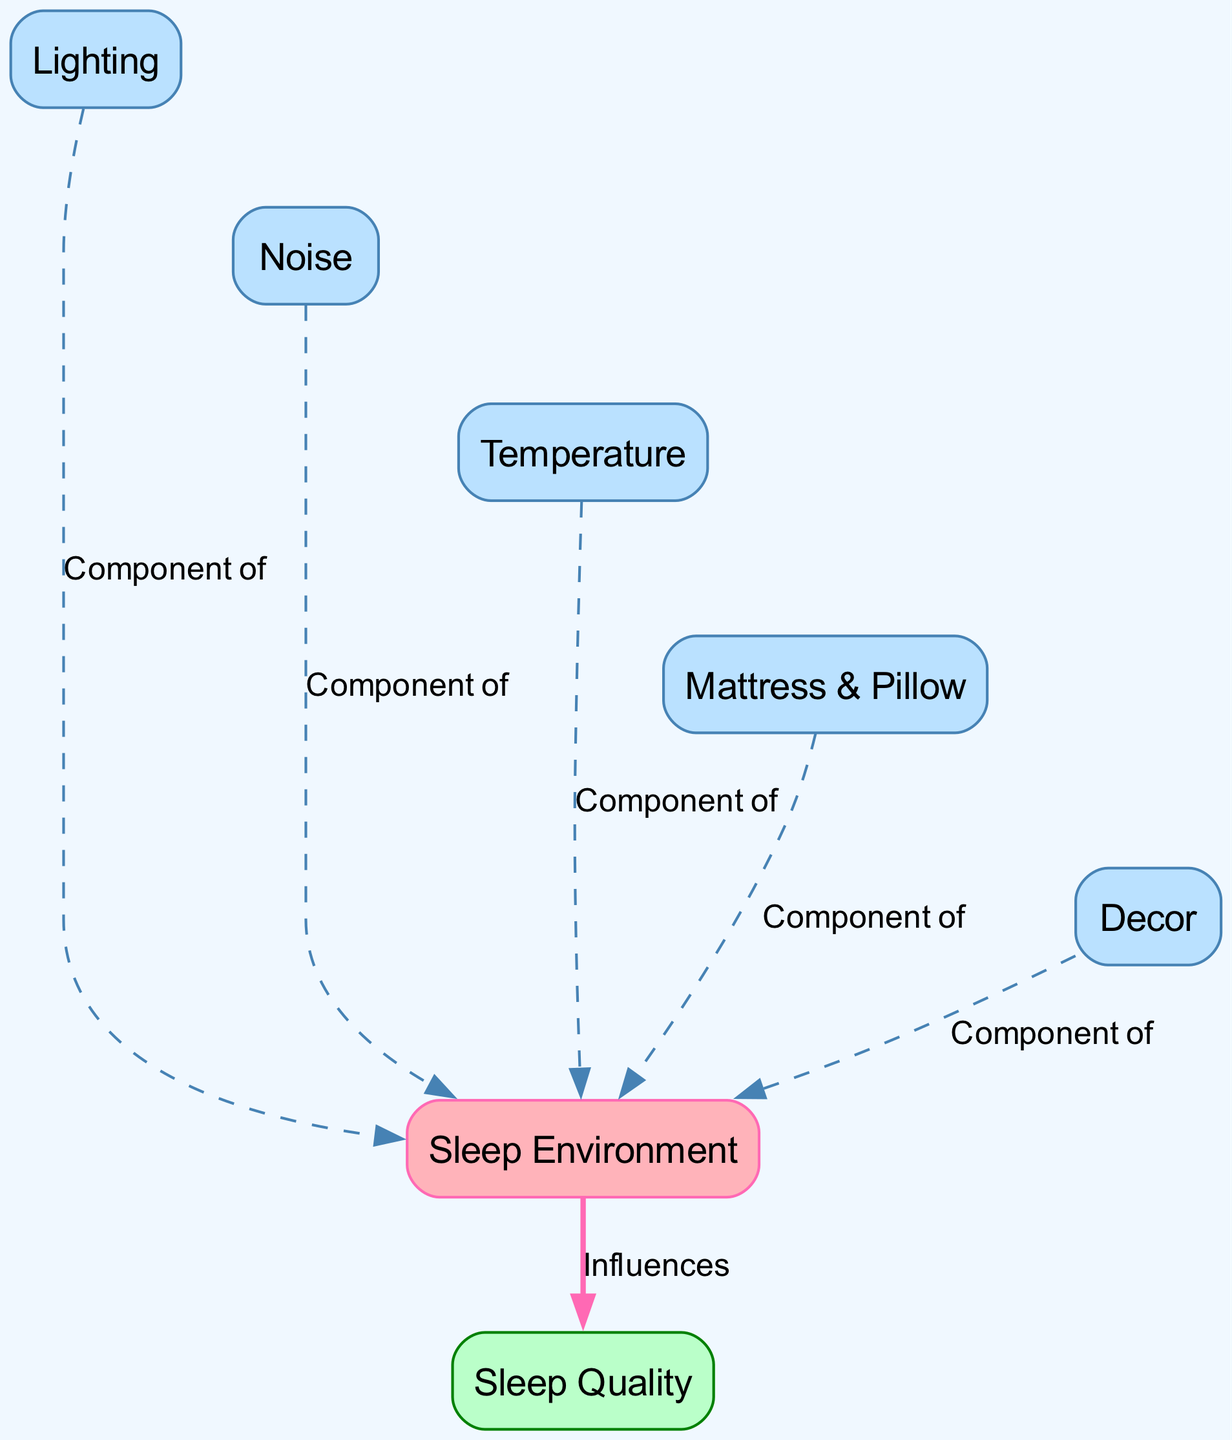What is the main theme of the diagram? The diagram illustrates the relationship between sleep environments and sleep quality. It highlights how various components of the sleep environment, such as lighting, noise, temperature, mattress & pillow, and decor, influence overall sleep quality.
Answer: Influence of sleep environments on sleep quality How many components are listed as part of the sleep environment? The diagram includes five components that contribute to the sleep environment: lighting, noise, temperature, mattress & pillow, and decor. By counting these specific nodes connected to sleep environment, we find a total of five.
Answer: Five What influences sleep quality according to the diagram? The diagram shows that the sleep environment directly influences sleep quality. This is represented by the directed edge that connects them, indicating a relationship where the quality of sleep is affected by environmental factors.
Answer: Sleep environment Which component is specifically related to light? The diagram clearly establishes that "Lighting" is a component of the "Sleep Environment." Therefore, it is directly linked as a contributing factor under the sleep environment umbrella.
Answer: Lighting Are there any invisible edges in the diagram? Yes, the diagram includes invisible edges that connect the components of the sleep environment (light, noise, temperature, mattress & pillow, and decor). These edges help improve the layout but do not represent direct influence.
Answer: Yes What color represents the sleep quality node in the diagram? The "Sleep Quality" node is represented with a color fill of light green (#BAFFC9) and a border of dark green (#008000). This color differentiation helps to visually distinguish it from the other nodes representing components of the environment.
Answer: Light green Which two components are linked by a dashed edge? The "Noise" and "Sleep Environment" components are connected with a dashed edge. The dashed line indicates a relationship where noise is a component of the sleep environment but does not influence it directly, representing a less strong connection.
Answer: Noise and sleep environment What is the color of the sleep environment node? The "Sleep Environment" node is highlighted with a pink color fill (#FFB3BA) and a border of hot pink (#FF69B4). This particular color schema is used to signify its role as a primary node in the diagram.
Answer: Pink 